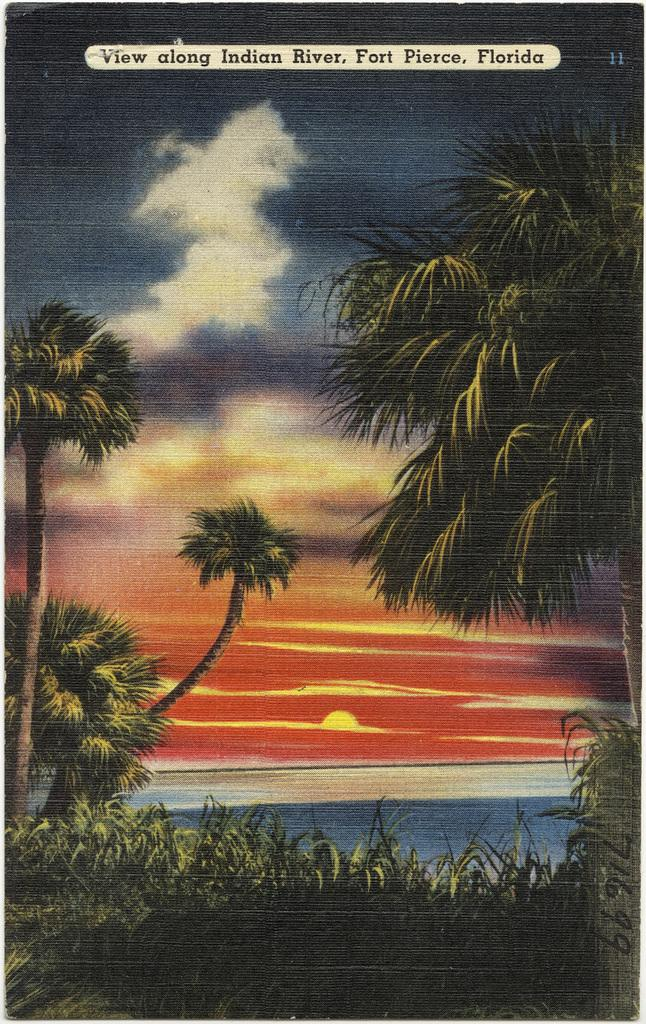What type of visual is depicted in the image? The image appears to be a poster. What natural elements are present in the image? There are plants and trees in the image. What can be seen in the sky in the image? Clouds and the sun are visible in the sky. What type of behavior is exhibited by the plants in the image? The image does not depict any behavior by the plants; it simply shows their presence. How does the sun aid in the digestion of the plants in the image? The image does not show any digestion process; it only displays the sun and plants as separate elements. 